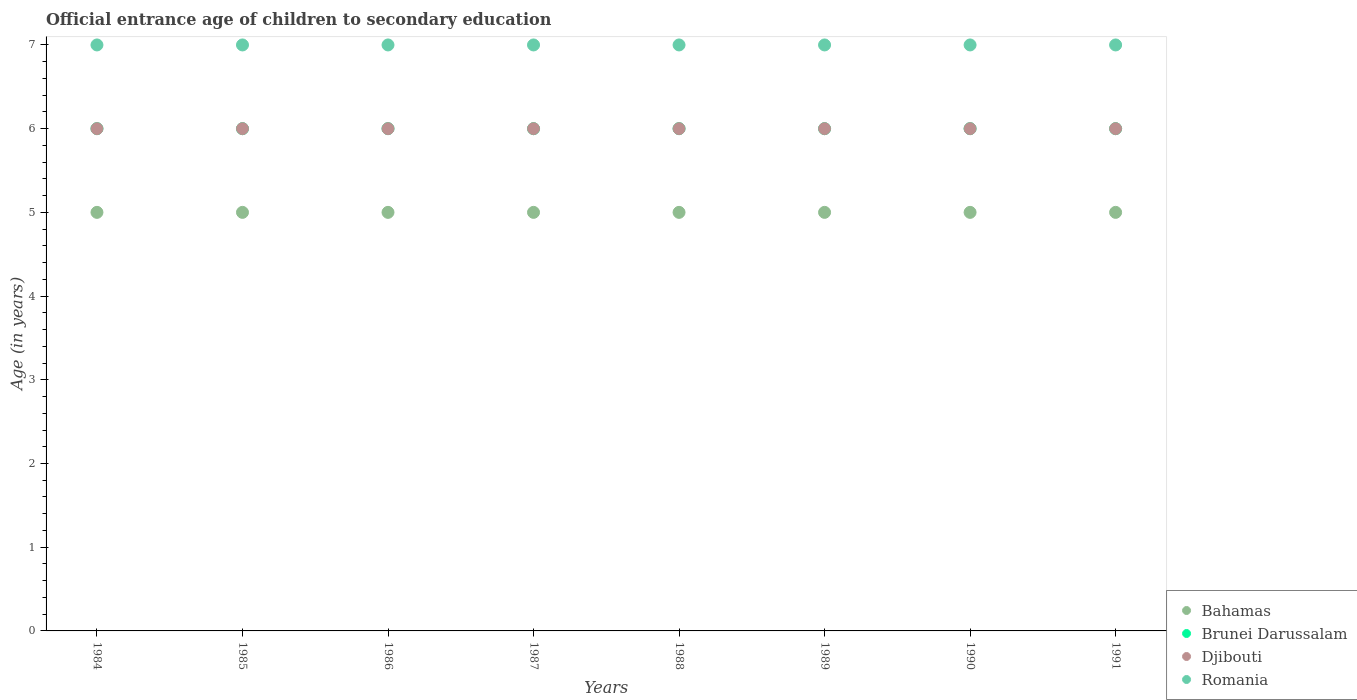Is the number of dotlines equal to the number of legend labels?
Your answer should be very brief. Yes. What is the secondary school starting age of children in Brunei Darussalam in 1991?
Make the answer very short. 6. Across all years, what is the minimum secondary school starting age of children in Brunei Darussalam?
Your response must be concise. 6. In which year was the secondary school starting age of children in Bahamas minimum?
Keep it short and to the point. 1984. What is the total secondary school starting age of children in Brunei Darussalam in the graph?
Keep it short and to the point. 48. What is the difference between the secondary school starting age of children in Djibouti in 1985 and the secondary school starting age of children in Bahamas in 1984?
Give a very brief answer. 1. What is the average secondary school starting age of children in Brunei Darussalam per year?
Keep it short and to the point. 6. In the year 1987, what is the difference between the secondary school starting age of children in Romania and secondary school starting age of children in Djibouti?
Provide a succinct answer. 1. What is the ratio of the secondary school starting age of children in Brunei Darussalam in 1985 to that in 1991?
Your answer should be compact. 1. Is the difference between the secondary school starting age of children in Romania in 1985 and 1991 greater than the difference between the secondary school starting age of children in Djibouti in 1985 and 1991?
Your response must be concise. No. What is the difference between the highest and the lowest secondary school starting age of children in Bahamas?
Make the answer very short. 0. Does the secondary school starting age of children in Djibouti monotonically increase over the years?
Your response must be concise. No. How many years are there in the graph?
Offer a very short reply. 8. Are the values on the major ticks of Y-axis written in scientific E-notation?
Provide a succinct answer. No. Does the graph contain any zero values?
Keep it short and to the point. No. Does the graph contain grids?
Offer a very short reply. No. Where does the legend appear in the graph?
Offer a terse response. Bottom right. What is the title of the graph?
Provide a succinct answer. Official entrance age of children to secondary education. Does "Sweden" appear as one of the legend labels in the graph?
Ensure brevity in your answer.  No. What is the label or title of the X-axis?
Provide a short and direct response. Years. What is the label or title of the Y-axis?
Offer a very short reply. Age (in years). What is the Age (in years) in Brunei Darussalam in 1984?
Ensure brevity in your answer.  6. What is the Age (in years) in Djibouti in 1985?
Ensure brevity in your answer.  6. What is the Age (in years) of Romania in 1985?
Make the answer very short. 7. What is the Age (in years) in Brunei Darussalam in 1986?
Offer a terse response. 6. What is the Age (in years) of Bahamas in 1987?
Your answer should be very brief. 5. What is the Age (in years) of Brunei Darussalam in 1987?
Make the answer very short. 6. What is the Age (in years) in Romania in 1987?
Offer a very short reply. 7. What is the Age (in years) in Romania in 1988?
Keep it short and to the point. 7. What is the Age (in years) in Bahamas in 1989?
Keep it short and to the point. 5. What is the Age (in years) in Bahamas in 1990?
Provide a succinct answer. 5. What is the Age (in years) of Brunei Darussalam in 1990?
Offer a very short reply. 6. What is the Age (in years) of Romania in 1990?
Keep it short and to the point. 7. Across all years, what is the maximum Age (in years) of Bahamas?
Make the answer very short. 5. Across all years, what is the maximum Age (in years) in Brunei Darussalam?
Make the answer very short. 6. Across all years, what is the minimum Age (in years) of Bahamas?
Your answer should be very brief. 5. Across all years, what is the minimum Age (in years) of Brunei Darussalam?
Your answer should be very brief. 6. Across all years, what is the minimum Age (in years) in Djibouti?
Provide a succinct answer. 6. What is the total Age (in years) in Romania in the graph?
Ensure brevity in your answer.  56. What is the difference between the Age (in years) in Djibouti in 1984 and that in 1985?
Your answer should be very brief. 0. What is the difference between the Age (in years) in Romania in 1984 and that in 1985?
Make the answer very short. 0. What is the difference between the Age (in years) of Bahamas in 1984 and that in 1986?
Offer a very short reply. 0. What is the difference between the Age (in years) in Romania in 1984 and that in 1986?
Make the answer very short. 0. What is the difference between the Age (in years) in Bahamas in 1984 and that in 1987?
Offer a terse response. 0. What is the difference between the Age (in years) in Djibouti in 1984 and that in 1987?
Your answer should be very brief. 0. What is the difference between the Age (in years) in Bahamas in 1984 and that in 1988?
Your answer should be compact. 0. What is the difference between the Age (in years) in Brunei Darussalam in 1984 and that in 1988?
Provide a short and direct response. 0. What is the difference between the Age (in years) in Djibouti in 1984 and that in 1988?
Ensure brevity in your answer.  0. What is the difference between the Age (in years) in Romania in 1984 and that in 1988?
Ensure brevity in your answer.  0. What is the difference between the Age (in years) in Bahamas in 1984 and that in 1989?
Your response must be concise. 0. What is the difference between the Age (in years) in Brunei Darussalam in 1984 and that in 1990?
Give a very brief answer. 0. What is the difference between the Age (in years) of Romania in 1984 and that in 1990?
Make the answer very short. 0. What is the difference between the Age (in years) in Bahamas in 1984 and that in 1991?
Ensure brevity in your answer.  0. What is the difference between the Age (in years) of Brunei Darussalam in 1984 and that in 1991?
Offer a very short reply. 0. What is the difference between the Age (in years) in Romania in 1984 and that in 1991?
Keep it short and to the point. 0. What is the difference between the Age (in years) of Bahamas in 1985 and that in 1986?
Your answer should be compact. 0. What is the difference between the Age (in years) of Djibouti in 1985 and that in 1986?
Your answer should be very brief. 0. What is the difference between the Age (in years) of Bahamas in 1985 and that in 1988?
Keep it short and to the point. 0. What is the difference between the Age (in years) of Brunei Darussalam in 1985 and that in 1988?
Provide a succinct answer. 0. What is the difference between the Age (in years) in Bahamas in 1985 and that in 1989?
Ensure brevity in your answer.  0. What is the difference between the Age (in years) of Brunei Darussalam in 1985 and that in 1989?
Ensure brevity in your answer.  0. What is the difference between the Age (in years) of Romania in 1985 and that in 1989?
Keep it short and to the point. 0. What is the difference between the Age (in years) in Djibouti in 1985 and that in 1990?
Offer a very short reply. 0. What is the difference between the Age (in years) of Romania in 1985 and that in 1990?
Give a very brief answer. 0. What is the difference between the Age (in years) in Bahamas in 1985 and that in 1991?
Your response must be concise. 0. What is the difference between the Age (in years) of Djibouti in 1985 and that in 1991?
Keep it short and to the point. 0. What is the difference between the Age (in years) of Bahamas in 1986 and that in 1987?
Make the answer very short. 0. What is the difference between the Age (in years) in Djibouti in 1986 and that in 1987?
Ensure brevity in your answer.  0. What is the difference between the Age (in years) of Brunei Darussalam in 1986 and that in 1988?
Offer a terse response. 0. What is the difference between the Age (in years) of Romania in 1986 and that in 1988?
Provide a short and direct response. 0. What is the difference between the Age (in years) of Bahamas in 1986 and that in 1989?
Provide a short and direct response. 0. What is the difference between the Age (in years) in Djibouti in 1986 and that in 1989?
Your answer should be compact. 0. What is the difference between the Age (in years) of Bahamas in 1986 and that in 1990?
Keep it short and to the point. 0. What is the difference between the Age (in years) in Romania in 1986 and that in 1990?
Keep it short and to the point. 0. What is the difference between the Age (in years) in Bahamas in 1986 and that in 1991?
Offer a terse response. 0. What is the difference between the Age (in years) of Romania in 1986 and that in 1991?
Your answer should be very brief. 0. What is the difference between the Age (in years) of Bahamas in 1987 and that in 1988?
Make the answer very short. 0. What is the difference between the Age (in years) in Djibouti in 1987 and that in 1988?
Your answer should be very brief. 0. What is the difference between the Age (in years) in Romania in 1987 and that in 1990?
Your response must be concise. 0. What is the difference between the Age (in years) in Bahamas in 1987 and that in 1991?
Give a very brief answer. 0. What is the difference between the Age (in years) of Djibouti in 1987 and that in 1991?
Make the answer very short. 0. What is the difference between the Age (in years) in Romania in 1987 and that in 1991?
Your answer should be compact. 0. What is the difference between the Age (in years) in Djibouti in 1988 and that in 1989?
Provide a short and direct response. 0. What is the difference between the Age (in years) of Bahamas in 1988 and that in 1990?
Give a very brief answer. 0. What is the difference between the Age (in years) in Brunei Darussalam in 1988 and that in 1990?
Offer a very short reply. 0. What is the difference between the Age (in years) in Djibouti in 1988 and that in 1990?
Keep it short and to the point. 0. What is the difference between the Age (in years) in Bahamas in 1988 and that in 1991?
Your answer should be very brief. 0. What is the difference between the Age (in years) of Brunei Darussalam in 1988 and that in 1991?
Make the answer very short. 0. What is the difference between the Age (in years) of Djibouti in 1988 and that in 1991?
Give a very brief answer. 0. What is the difference between the Age (in years) in Romania in 1988 and that in 1991?
Your answer should be compact. 0. What is the difference between the Age (in years) in Brunei Darussalam in 1989 and that in 1990?
Your answer should be compact. 0. What is the difference between the Age (in years) in Romania in 1989 and that in 1990?
Your response must be concise. 0. What is the difference between the Age (in years) of Romania in 1989 and that in 1991?
Make the answer very short. 0. What is the difference between the Age (in years) of Bahamas in 1990 and that in 1991?
Your response must be concise. 0. What is the difference between the Age (in years) in Djibouti in 1990 and that in 1991?
Keep it short and to the point. 0. What is the difference between the Age (in years) of Bahamas in 1984 and the Age (in years) of Romania in 1985?
Your answer should be very brief. -2. What is the difference between the Age (in years) in Brunei Darussalam in 1984 and the Age (in years) in Djibouti in 1985?
Offer a terse response. 0. What is the difference between the Age (in years) of Bahamas in 1984 and the Age (in years) of Djibouti in 1986?
Ensure brevity in your answer.  -1. What is the difference between the Age (in years) in Bahamas in 1984 and the Age (in years) in Romania in 1986?
Your answer should be compact. -2. What is the difference between the Age (in years) in Brunei Darussalam in 1984 and the Age (in years) in Romania in 1986?
Your answer should be compact. -1. What is the difference between the Age (in years) in Djibouti in 1984 and the Age (in years) in Romania in 1986?
Your response must be concise. -1. What is the difference between the Age (in years) in Brunei Darussalam in 1984 and the Age (in years) in Romania in 1987?
Your response must be concise. -1. What is the difference between the Age (in years) in Djibouti in 1984 and the Age (in years) in Romania in 1987?
Make the answer very short. -1. What is the difference between the Age (in years) of Bahamas in 1984 and the Age (in years) of Brunei Darussalam in 1988?
Ensure brevity in your answer.  -1. What is the difference between the Age (in years) of Bahamas in 1984 and the Age (in years) of Djibouti in 1988?
Provide a short and direct response. -1. What is the difference between the Age (in years) of Brunei Darussalam in 1984 and the Age (in years) of Djibouti in 1988?
Offer a very short reply. 0. What is the difference between the Age (in years) of Brunei Darussalam in 1984 and the Age (in years) of Romania in 1988?
Provide a succinct answer. -1. What is the difference between the Age (in years) in Djibouti in 1984 and the Age (in years) in Romania in 1988?
Your answer should be very brief. -1. What is the difference between the Age (in years) of Bahamas in 1984 and the Age (in years) of Djibouti in 1989?
Give a very brief answer. -1. What is the difference between the Age (in years) in Bahamas in 1984 and the Age (in years) in Romania in 1989?
Your answer should be very brief. -2. What is the difference between the Age (in years) of Brunei Darussalam in 1984 and the Age (in years) of Djibouti in 1989?
Offer a terse response. 0. What is the difference between the Age (in years) in Bahamas in 1984 and the Age (in years) in Brunei Darussalam in 1990?
Provide a succinct answer. -1. What is the difference between the Age (in years) of Brunei Darussalam in 1984 and the Age (in years) of Djibouti in 1990?
Your answer should be compact. 0. What is the difference between the Age (in years) of Brunei Darussalam in 1984 and the Age (in years) of Romania in 1990?
Provide a short and direct response. -1. What is the difference between the Age (in years) of Djibouti in 1984 and the Age (in years) of Romania in 1990?
Offer a very short reply. -1. What is the difference between the Age (in years) of Bahamas in 1984 and the Age (in years) of Romania in 1991?
Your response must be concise. -2. What is the difference between the Age (in years) of Brunei Darussalam in 1984 and the Age (in years) of Djibouti in 1991?
Your answer should be compact. 0. What is the difference between the Age (in years) of Brunei Darussalam in 1984 and the Age (in years) of Romania in 1991?
Ensure brevity in your answer.  -1. What is the difference between the Age (in years) in Djibouti in 1984 and the Age (in years) in Romania in 1991?
Your answer should be very brief. -1. What is the difference between the Age (in years) in Bahamas in 1985 and the Age (in years) in Brunei Darussalam in 1986?
Your answer should be very brief. -1. What is the difference between the Age (in years) in Bahamas in 1985 and the Age (in years) in Romania in 1986?
Offer a very short reply. -2. What is the difference between the Age (in years) of Brunei Darussalam in 1985 and the Age (in years) of Djibouti in 1986?
Provide a short and direct response. 0. What is the difference between the Age (in years) in Brunei Darussalam in 1985 and the Age (in years) in Romania in 1986?
Offer a very short reply. -1. What is the difference between the Age (in years) of Djibouti in 1985 and the Age (in years) of Romania in 1986?
Your response must be concise. -1. What is the difference between the Age (in years) of Brunei Darussalam in 1985 and the Age (in years) of Djibouti in 1987?
Your answer should be very brief. 0. What is the difference between the Age (in years) in Brunei Darussalam in 1985 and the Age (in years) in Romania in 1987?
Provide a succinct answer. -1. What is the difference between the Age (in years) of Bahamas in 1985 and the Age (in years) of Djibouti in 1988?
Ensure brevity in your answer.  -1. What is the difference between the Age (in years) of Bahamas in 1985 and the Age (in years) of Romania in 1988?
Your answer should be compact. -2. What is the difference between the Age (in years) in Brunei Darussalam in 1985 and the Age (in years) in Djibouti in 1988?
Offer a very short reply. 0. What is the difference between the Age (in years) of Brunei Darussalam in 1985 and the Age (in years) of Romania in 1988?
Your answer should be compact. -1. What is the difference between the Age (in years) in Bahamas in 1985 and the Age (in years) in Romania in 1989?
Make the answer very short. -2. What is the difference between the Age (in years) in Brunei Darussalam in 1985 and the Age (in years) in Djibouti in 1989?
Ensure brevity in your answer.  0. What is the difference between the Age (in years) of Djibouti in 1985 and the Age (in years) of Romania in 1989?
Provide a short and direct response. -1. What is the difference between the Age (in years) of Bahamas in 1985 and the Age (in years) of Djibouti in 1990?
Make the answer very short. -1. What is the difference between the Age (in years) of Djibouti in 1985 and the Age (in years) of Romania in 1990?
Provide a short and direct response. -1. What is the difference between the Age (in years) of Bahamas in 1985 and the Age (in years) of Brunei Darussalam in 1991?
Your response must be concise. -1. What is the difference between the Age (in years) in Brunei Darussalam in 1985 and the Age (in years) in Djibouti in 1991?
Your answer should be very brief. 0. What is the difference between the Age (in years) of Brunei Darussalam in 1985 and the Age (in years) of Romania in 1991?
Your response must be concise. -1. What is the difference between the Age (in years) in Djibouti in 1985 and the Age (in years) in Romania in 1991?
Provide a succinct answer. -1. What is the difference between the Age (in years) in Bahamas in 1986 and the Age (in years) in Brunei Darussalam in 1987?
Your answer should be very brief. -1. What is the difference between the Age (in years) of Bahamas in 1986 and the Age (in years) of Djibouti in 1987?
Your response must be concise. -1. What is the difference between the Age (in years) of Bahamas in 1986 and the Age (in years) of Romania in 1987?
Provide a succinct answer. -2. What is the difference between the Age (in years) of Brunei Darussalam in 1986 and the Age (in years) of Romania in 1987?
Give a very brief answer. -1. What is the difference between the Age (in years) of Bahamas in 1986 and the Age (in years) of Brunei Darussalam in 1988?
Your response must be concise. -1. What is the difference between the Age (in years) in Bahamas in 1986 and the Age (in years) in Romania in 1988?
Provide a short and direct response. -2. What is the difference between the Age (in years) of Brunei Darussalam in 1986 and the Age (in years) of Djibouti in 1988?
Your answer should be very brief. 0. What is the difference between the Age (in years) of Brunei Darussalam in 1986 and the Age (in years) of Romania in 1988?
Offer a terse response. -1. What is the difference between the Age (in years) of Djibouti in 1986 and the Age (in years) of Romania in 1988?
Offer a very short reply. -1. What is the difference between the Age (in years) in Bahamas in 1986 and the Age (in years) in Djibouti in 1989?
Your response must be concise. -1. What is the difference between the Age (in years) of Brunei Darussalam in 1986 and the Age (in years) of Djibouti in 1989?
Give a very brief answer. 0. What is the difference between the Age (in years) in Djibouti in 1986 and the Age (in years) in Romania in 1989?
Your response must be concise. -1. What is the difference between the Age (in years) in Brunei Darussalam in 1986 and the Age (in years) in Romania in 1990?
Give a very brief answer. -1. What is the difference between the Age (in years) in Bahamas in 1986 and the Age (in years) in Brunei Darussalam in 1991?
Provide a short and direct response. -1. What is the difference between the Age (in years) of Bahamas in 1986 and the Age (in years) of Djibouti in 1991?
Your answer should be compact. -1. What is the difference between the Age (in years) in Brunei Darussalam in 1986 and the Age (in years) in Romania in 1991?
Offer a terse response. -1. What is the difference between the Age (in years) in Bahamas in 1987 and the Age (in years) in Brunei Darussalam in 1988?
Offer a very short reply. -1. What is the difference between the Age (in years) of Brunei Darussalam in 1987 and the Age (in years) of Djibouti in 1988?
Your answer should be compact. 0. What is the difference between the Age (in years) of Brunei Darussalam in 1987 and the Age (in years) of Romania in 1988?
Offer a terse response. -1. What is the difference between the Age (in years) of Djibouti in 1987 and the Age (in years) of Romania in 1988?
Offer a very short reply. -1. What is the difference between the Age (in years) in Bahamas in 1987 and the Age (in years) in Djibouti in 1989?
Your response must be concise. -1. What is the difference between the Age (in years) in Brunei Darussalam in 1987 and the Age (in years) in Djibouti in 1989?
Offer a very short reply. 0. What is the difference between the Age (in years) in Djibouti in 1987 and the Age (in years) in Romania in 1989?
Your answer should be compact. -1. What is the difference between the Age (in years) of Bahamas in 1987 and the Age (in years) of Djibouti in 1990?
Your answer should be very brief. -1. What is the difference between the Age (in years) in Bahamas in 1987 and the Age (in years) in Romania in 1990?
Your response must be concise. -2. What is the difference between the Age (in years) of Djibouti in 1987 and the Age (in years) of Romania in 1990?
Give a very brief answer. -1. What is the difference between the Age (in years) in Bahamas in 1987 and the Age (in years) in Brunei Darussalam in 1991?
Keep it short and to the point. -1. What is the difference between the Age (in years) in Bahamas in 1987 and the Age (in years) in Djibouti in 1991?
Your response must be concise. -1. What is the difference between the Age (in years) of Bahamas in 1987 and the Age (in years) of Romania in 1991?
Your answer should be very brief. -2. What is the difference between the Age (in years) of Brunei Darussalam in 1987 and the Age (in years) of Djibouti in 1991?
Your answer should be very brief. 0. What is the difference between the Age (in years) in Bahamas in 1988 and the Age (in years) in Djibouti in 1989?
Offer a terse response. -1. What is the difference between the Age (in years) of Bahamas in 1988 and the Age (in years) of Romania in 1989?
Your response must be concise. -2. What is the difference between the Age (in years) of Djibouti in 1988 and the Age (in years) of Romania in 1989?
Provide a succinct answer. -1. What is the difference between the Age (in years) in Bahamas in 1988 and the Age (in years) in Brunei Darussalam in 1990?
Ensure brevity in your answer.  -1. What is the difference between the Age (in years) in Djibouti in 1988 and the Age (in years) in Romania in 1990?
Keep it short and to the point. -1. What is the difference between the Age (in years) of Bahamas in 1988 and the Age (in years) of Brunei Darussalam in 1991?
Your answer should be very brief. -1. What is the difference between the Age (in years) of Bahamas in 1988 and the Age (in years) of Romania in 1991?
Offer a very short reply. -2. What is the difference between the Age (in years) in Brunei Darussalam in 1988 and the Age (in years) in Djibouti in 1991?
Ensure brevity in your answer.  0. What is the difference between the Age (in years) of Brunei Darussalam in 1988 and the Age (in years) of Romania in 1991?
Ensure brevity in your answer.  -1. What is the difference between the Age (in years) of Djibouti in 1988 and the Age (in years) of Romania in 1991?
Provide a short and direct response. -1. What is the difference between the Age (in years) of Bahamas in 1989 and the Age (in years) of Romania in 1990?
Your response must be concise. -2. What is the difference between the Age (in years) in Brunei Darussalam in 1989 and the Age (in years) in Djibouti in 1990?
Your answer should be very brief. 0. What is the difference between the Age (in years) of Brunei Darussalam in 1989 and the Age (in years) of Romania in 1990?
Make the answer very short. -1. What is the difference between the Age (in years) of Bahamas in 1989 and the Age (in years) of Djibouti in 1991?
Make the answer very short. -1. What is the difference between the Age (in years) in Brunei Darussalam in 1989 and the Age (in years) in Djibouti in 1991?
Offer a terse response. 0. What is the difference between the Age (in years) in Brunei Darussalam in 1989 and the Age (in years) in Romania in 1991?
Offer a very short reply. -1. What is the difference between the Age (in years) in Bahamas in 1990 and the Age (in years) in Djibouti in 1991?
Your answer should be very brief. -1. What is the difference between the Age (in years) in Bahamas in 1990 and the Age (in years) in Romania in 1991?
Offer a terse response. -2. What is the difference between the Age (in years) in Brunei Darussalam in 1990 and the Age (in years) in Romania in 1991?
Provide a succinct answer. -1. What is the difference between the Age (in years) in Djibouti in 1990 and the Age (in years) in Romania in 1991?
Your response must be concise. -1. What is the average Age (in years) in Bahamas per year?
Keep it short and to the point. 5. What is the average Age (in years) of Djibouti per year?
Your answer should be very brief. 6. In the year 1984, what is the difference between the Age (in years) in Brunei Darussalam and Age (in years) in Romania?
Provide a succinct answer. -1. In the year 1984, what is the difference between the Age (in years) in Djibouti and Age (in years) in Romania?
Provide a succinct answer. -1. In the year 1985, what is the difference between the Age (in years) in Bahamas and Age (in years) in Djibouti?
Provide a succinct answer. -1. In the year 1985, what is the difference between the Age (in years) in Bahamas and Age (in years) in Romania?
Your answer should be very brief. -2. In the year 1985, what is the difference between the Age (in years) in Brunei Darussalam and Age (in years) in Djibouti?
Make the answer very short. 0. In the year 1986, what is the difference between the Age (in years) of Bahamas and Age (in years) of Romania?
Give a very brief answer. -2. In the year 1987, what is the difference between the Age (in years) in Bahamas and Age (in years) in Djibouti?
Offer a very short reply. -1. In the year 1987, what is the difference between the Age (in years) in Brunei Darussalam and Age (in years) in Romania?
Give a very brief answer. -1. In the year 1987, what is the difference between the Age (in years) of Djibouti and Age (in years) of Romania?
Provide a short and direct response. -1. In the year 1988, what is the difference between the Age (in years) in Bahamas and Age (in years) in Brunei Darussalam?
Your answer should be compact. -1. In the year 1988, what is the difference between the Age (in years) of Bahamas and Age (in years) of Romania?
Keep it short and to the point. -2. In the year 1989, what is the difference between the Age (in years) in Bahamas and Age (in years) in Djibouti?
Your response must be concise. -1. In the year 1990, what is the difference between the Age (in years) in Bahamas and Age (in years) in Djibouti?
Your answer should be compact. -1. In the year 1990, what is the difference between the Age (in years) of Brunei Darussalam and Age (in years) of Djibouti?
Your response must be concise. 0. In the year 1990, what is the difference between the Age (in years) of Brunei Darussalam and Age (in years) of Romania?
Offer a terse response. -1. In the year 1991, what is the difference between the Age (in years) of Bahamas and Age (in years) of Djibouti?
Make the answer very short. -1. In the year 1991, what is the difference between the Age (in years) in Brunei Darussalam and Age (in years) in Djibouti?
Provide a succinct answer. 0. What is the ratio of the Age (in years) of Brunei Darussalam in 1984 to that in 1985?
Ensure brevity in your answer.  1. What is the ratio of the Age (in years) of Brunei Darussalam in 1984 to that in 1987?
Your response must be concise. 1. What is the ratio of the Age (in years) of Romania in 1984 to that in 1988?
Your answer should be compact. 1. What is the ratio of the Age (in years) in Brunei Darussalam in 1984 to that in 1989?
Your answer should be very brief. 1. What is the ratio of the Age (in years) in Romania in 1984 to that in 1989?
Your answer should be very brief. 1. What is the ratio of the Age (in years) of Romania in 1984 to that in 1990?
Make the answer very short. 1. What is the ratio of the Age (in years) of Bahamas in 1984 to that in 1991?
Your response must be concise. 1. What is the ratio of the Age (in years) of Brunei Darussalam in 1984 to that in 1991?
Make the answer very short. 1. What is the ratio of the Age (in years) of Romania in 1984 to that in 1991?
Give a very brief answer. 1. What is the ratio of the Age (in years) in Brunei Darussalam in 1985 to that in 1986?
Give a very brief answer. 1. What is the ratio of the Age (in years) of Djibouti in 1985 to that in 1987?
Offer a terse response. 1. What is the ratio of the Age (in years) of Romania in 1985 to that in 1987?
Give a very brief answer. 1. What is the ratio of the Age (in years) of Djibouti in 1985 to that in 1988?
Provide a short and direct response. 1. What is the ratio of the Age (in years) of Bahamas in 1985 to that in 1989?
Your answer should be very brief. 1. What is the ratio of the Age (in years) in Brunei Darussalam in 1985 to that in 1989?
Offer a very short reply. 1. What is the ratio of the Age (in years) in Romania in 1985 to that in 1989?
Your answer should be very brief. 1. What is the ratio of the Age (in years) of Brunei Darussalam in 1985 to that in 1990?
Offer a very short reply. 1. What is the ratio of the Age (in years) of Bahamas in 1985 to that in 1991?
Your answer should be compact. 1. What is the ratio of the Age (in years) of Djibouti in 1985 to that in 1991?
Your response must be concise. 1. What is the ratio of the Age (in years) of Bahamas in 1986 to that in 1987?
Make the answer very short. 1. What is the ratio of the Age (in years) of Romania in 1986 to that in 1987?
Provide a short and direct response. 1. What is the ratio of the Age (in years) in Brunei Darussalam in 1986 to that in 1988?
Make the answer very short. 1. What is the ratio of the Age (in years) of Romania in 1986 to that in 1988?
Your answer should be very brief. 1. What is the ratio of the Age (in years) in Djibouti in 1986 to that in 1989?
Offer a very short reply. 1. What is the ratio of the Age (in years) in Romania in 1986 to that in 1989?
Provide a succinct answer. 1. What is the ratio of the Age (in years) in Bahamas in 1986 to that in 1990?
Your response must be concise. 1. What is the ratio of the Age (in years) in Djibouti in 1986 to that in 1990?
Give a very brief answer. 1. What is the ratio of the Age (in years) of Djibouti in 1986 to that in 1991?
Keep it short and to the point. 1. What is the ratio of the Age (in years) in Bahamas in 1987 to that in 1988?
Provide a short and direct response. 1. What is the ratio of the Age (in years) in Brunei Darussalam in 1987 to that in 1988?
Give a very brief answer. 1. What is the ratio of the Age (in years) of Bahamas in 1987 to that in 1989?
Offer a terse response. 1. What is the ratio of the Age (in years) in Romania in 1987 to that in 1989?
Offer a terse response. 1. What is the ratio of the Age (in years) in Djibouti in 1987 to that in 1990?
Provide a succinct answer. 1. What is the ratio of the Age (in years) in Romania in 1987 to that in 1990?
Give a very brief answer. 1. What is the ratio of the Age (in years) of Brunei Darussalam in 1987 to that in 1991?
Provide a short and direct response. 1. What is the ratio of the Age (in years) of Djibouti in 1987 to that in 1991?
Offer a very short reply. 1. What is the ratio of the Age (in years) of Romania in 1988 to that in 1989?
Your response must be concise. 1. What is the ratio of the Age (in years) of Brunei Darussalam in 1988 to that in 1990?
Keep it short and to the point. 1. What is the ratio of the Age (in years) of Djibouti in 1988 to that in 1990?
Keep it short and to the point. 1. What is the ratio of the Age (in years) of Romania in 1988 to that in 1990?
Make the answer very short. 1. What is the ratio of the Age (in years) of Bahamas in 1988 to that in 1991?
Your answer should be compact. 1. What is the ratio of the Age (in years) in Brunei Darussalam in 1988 to that in 1991?
Give a very brief answer. 1. What is the ratio of the Age (in years) of Romania in 1988 to that in 1991?
Your answer should be very brief. 1. What is the ratio of the Age (in years) in Bahamas in 1989 to that in 1990?
Your answer should be very brief. 1. What is the ratio of the Age (in years) in Djibouti in 1989 to that in 1990?
Give a very brief answer. 1. What is the ratio of the Age (in years) of Romania in 1989 to that in 1990?
Your answer should be compact. 1. What is the ratio of the Age (in years) of Bahamas in 1989 to that in 1991?
Your response must be concise. 1. What is the ratio of the Age (in years) of Brunei Darussalam in 1989 to that in 1991?
Your answer should be compact. 1. What is the ratio of the Age (in years) of Djibouti in 1989 to that in 1991?
Your answer should be compact. 1. What is the ratio of the Age (in years) in Djibouti in 1990 to that in 1991?
Offer a terse response. 1. What is the ratio of the Age (in years) of Romania in 1990 to that in 1991?
Your response must be concise. 1. What is the difference between the highest and the second highest Age (in years) of Brunei Darussalam?
Make the answer very short. 0. What is the difference between the highest and the second highest Age (in years) in Djibouti?
Your response must be concise. 0. What is the difference between the highest and the lowest Age (in years) of Bahamas?
Your response must be concise. 0. 